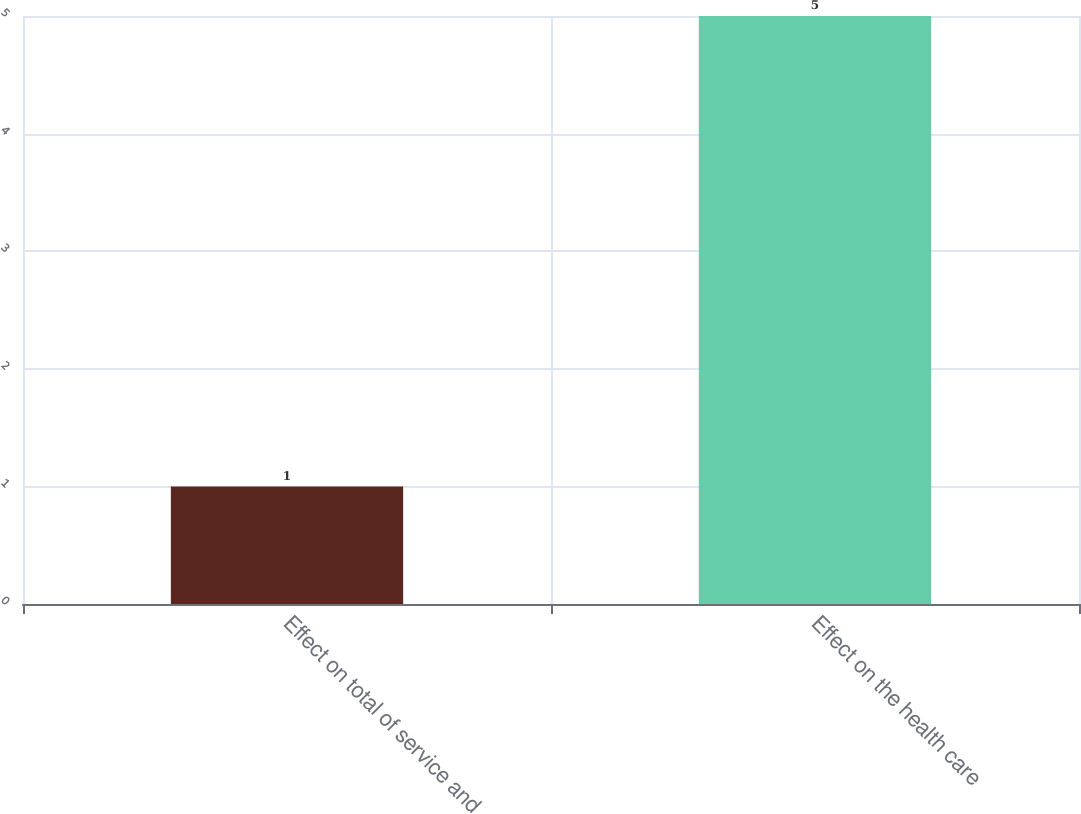Convert chart to OTSL. <chart><loc_0><loc_0><loc_500><loc_500><bar_chart><fcel>Effect on total of service and<fcel>Effect on the health care<nl><fcel>1<fcel>5<nl></chart> 